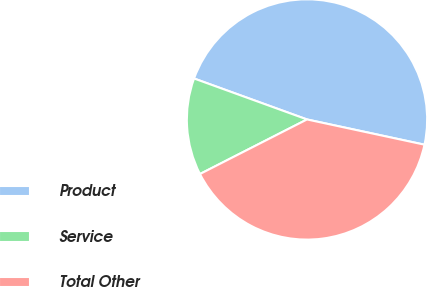<chart> <loc_0><loc_0><loc_500><loc_500><pie_chart><fcel>Product<fcel>Service<fcel>Total Other<nl><fcel>47.83%<fcel>13.04%<fcel>39.13%<nl></chart> 